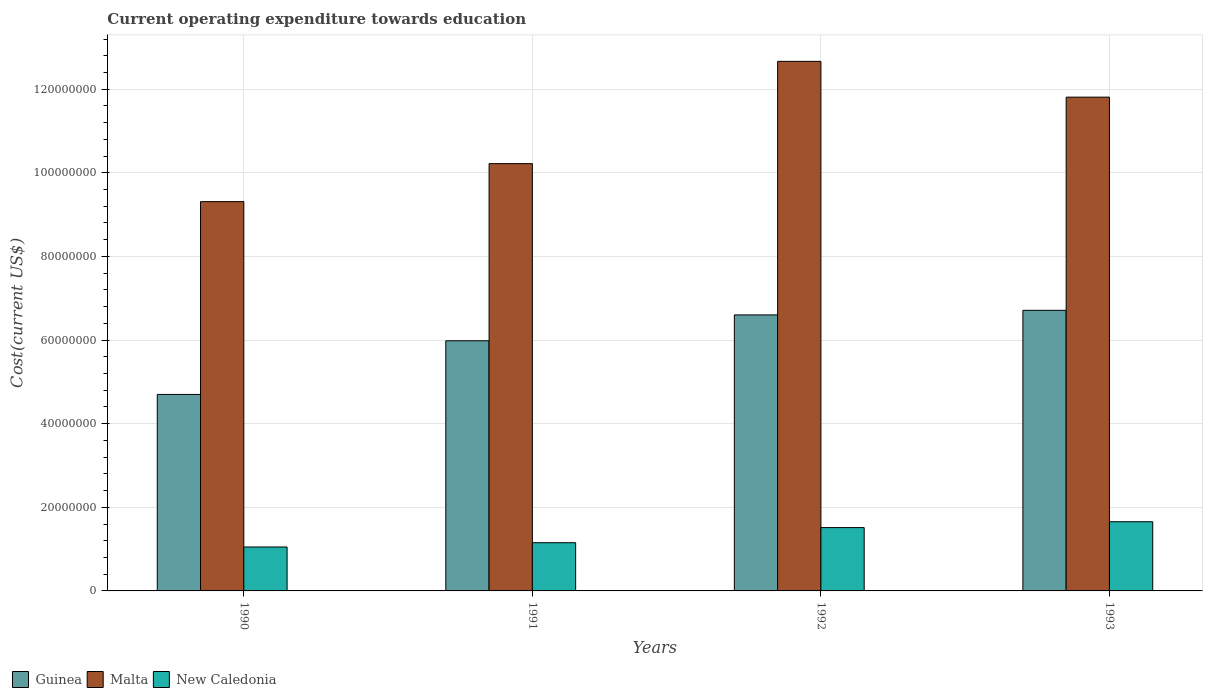How many different coloured bars are there?
Provide a succinct answer. 3. How many groups of bars are there?
Provide a succinct answer. 4. How many bars are there on the 2nd tick from the left?
Make the answer very short. 3. What is the label of the 2nd group of bars from the left?
Ensure brevity in your answer.  1991. In how many cases, is the number of bars for a given year not equal to the number of legend labels?
Your answer should be compact. 0. What is the expenditure towards education in New Caledonia in 1992?
Your answer should be very brief. 1.51e+07. Across all years, what is the maximum expenditure towards education in Guinea?
Your answer should be very brief. 6.71e+07. Across all years, what is the minimum expenditure towards education in Guinea?
Offer a terse response. 4.70e+07. In which year was the expenditure towards education in Malta minimum?
Offer a very short reply. 1990. What is the total expenditure towards education in New Caledonia in the graph?
Your response must be concise. 5.37e+07. What is the difference between the expenditure towards education in Malta in 1990 and that in 1993?
Offer a very short reply. -2.50e+07. What is the difference between the expenditure towards education in Malta in 1992 and the expenditure towards education in Guinea in 1990?
Your answer should be very brief. 7.97e+07. What is the average expenditure towards education in Guinea per year?
Offer a very short reply. 6.00e+07. In the year 1993, what is the difference between the expenditure towards education in Malta and expenditure towards education in New Caledonia?
Your answer should be very brief. 1.02e+08. In how many years, is the expenditure towards education in Malta greater than 100000000 US$?
Provide a succinct answer. 3. What is the ratio of the expenditure towards education in Malta in 1991 to that in 1992?
Make the answer very short. 0.81. Is the difference between the expenditure towards education in Malta in 1991 and 1992 greater than the difference between the expenditure towards education in New Caledonia in 1991 and 1992?
Give a very brief answer. No. What is the difference between the highest and the second highest expenditure towards education in New Caledonia?
Your answer should be compact. 1.40e+06. What is the difference between the highest and the lowest expenditure towards education in New Caledonia?
Offer a terse response. 6.04e+06. In how many years, is the expenditure towards education in Guinea greater than the average expenditure towards education in Guinea taken over all years?
Give a very brief answer. 2. What does the 3rd bar from the left in 1991 represents?
Offer a terse response. New Caledonia. What does the 2nd bar from the right in 1992 represents?
Your answer should be compact. Malta. Is it the case that in every year, the sum of the expenditure towards education in New Caledonia and expenditure towards education in Malta is greater than the expenditure towards education in Guinea?
Your response must be concise. Yes. Are all the bars in the graph horizontal?
Your response must be concise. No. What is the difference between two consecutive major ticks on the Y-axis?
Give a very brief answer. 2.00e+07. Are the values on the major ticks of Y-axis written in scientific E-notation?
Give a very brief answer. No. Does the graph contain any zero values?
Your answer should be very brief. No. Does the graph contain grids?
Your answer should be very brief. Yes. Where does the legend appear in the graph?
Offer a very short reply. Bottom left. How many legend labels are there?
Provide a short and direct response. 3. How are the legend labels stacked?
Your answer should be compact. Horizontal. What is the title of the graph?
Give a very brief answer. Current operating expenditure towards education. Does "Tunisia" appear as one of the legend labels in the graph?
Your answer should be very brief. No. What is the label or title of the Y-axis?
Keep it short and to the point. Cost(current US$). What is the Cost(current US$) of Guinea in 1990?
Provide a short and direct response. 4.70e+07. What is the Cost(current US$) in Malta in 1990?
Provide a succinct answer. 9.31e+07. What is the Cost(current US$) in New Caledonia in 1990?
Offer a very short reply. 1.05e+07. What is the Cost(current US$) of Guinea in 1991?
Provide a short and direct response. 5.98e+07. What is the Cost(current US$) in Malta in 1991?
Your response must be concise. 1.02e+08. What is the Cost(current US$) of New Caledonia in 1991?
Your answer should be very brief. 1.15e+07. What is the Cost(current US$) in Guinea in 1992?
Your answer should be compact. 6.60e+07. What is the Cost(current US$) of Malta in 1992?
Ensure brevity in your answer.  1.27e+08. What is the Cost(current US$) in New Caledonia in 1992?
Offer a terse response. 1.51e+07. What is the Cost(current US$) of Guinea in 1993?
Provide a succinct answer. 6.71e+07. What is the Cost(current US$) in Malta in 1993?
Your answer should be very brief. 1.18e+08. What is the Cost(current US$) of New Caledonia in 1993?
Keep it short and to the point. 1.65e+07. Across all years, what is the maximum Cost(current US$) of Guinea?
Your response must be concise. 6.71e+07. Across all years, what is the maximum Cost(current US$) in Malta?
Ensure brevity in your answer.  1.27e+08. Across all years, what is the maximum Cost(current US$) of New Caledonia?
Provide a short and direct response. 1.65e+07. Across all years, what is the minimum Cost(current US$) of Guinea?
Ensure brevity in your answer.  4.70e+07. Across all years, what is the minimum Cost(current US$) of Malta?
Keep it short and to the point. 9.31e+07. Across all years, what is the minimum Cost(current US$) in New Caledonia?
Make the answer very short. 1.05e+07. What is the total Cost(current US$) of Guinea in the graph?
Make the answer very short. 2.40e+08. What is the total Cost(current US$) of Malta in the graph?
Your answer should be compact. 4.40e+08. What is the total Cost(current US$) of New Caledonia in the graph?
Your response must be concise. 5.37e+07. What is the difference between the Cost(current US$) in Guinea in 1990 and that in 1991?
Make the answer very short. -1.28e+07. What is the difference between the Cost(current US$) in Malta in 1990 and that in 1991?
Make the answer very short. -9.09e+06. What is the difference between the Cost(current US$) of New Caledonia in 1990 and that in 1991?
Your response must be concise. -1.03e+06. What is the difference between the Cost(current US$) in Guinea in 1990 and that in 1992?
Keep it short and to the point. -1.90e+07. What is the difference between the Cost(current US$) in Malta in 1990 and that in 1992?
Offer a terse response. -3.36e+07. What is the difference between the Cost(current US$) of New Caledonia in 1990 and that in 1992?
Ensure brevity in your answer.  -4.64e+06. What is the difference between the Cost(current US$) of Guinea in 1990 and that in 1993?
Keep it short and to the point. -2.01e+07. What is the difference between the Cost(current US$) of Malta in 1990 and that in 1993?
Your answer should be very brief. -2.50e+07. What is the difference between the Cost(current US$) in New Caledonia in 1990 and that in 1993?
Keep it short and to the point. -6.04e+06. What is the difference between the Cost(current US$) of Guinea in 1991 and that in 1992?
Offer a terse response. -6.19e+06. What is the difference between the Cost(current US$) of Malta in 1991 and that in 1992?
Your answer should be very brief. -2.45e+07. What is the difference between the Cost(current US$) of New Caledonia in 1991 and that in 1992?
Provide a succinct answer. -3.62e+06. What is the difference between the Cost(current US$) in Guinea in 1991 and that in 1993?
Ensure brevity in your answer.  -7.28e+06. What is the difference between the Cost(current US$) of Malta in 1991 and that in 1993?
Offer a very short reply. -1.59e+07. What is the difference between the Cost(current US$) in New Caledonia in 1991 and that in 1993?
Offer a very short reply. -5.01e+06. What is the difference between the Cost(current US$) in Guinea in 1992 and that in 1993?
Your answer should be compact. -1.09e+06. What is the difference between the Cost(current US$) in Malta in 1992 and that in 1993?
Offer a terse response. 8.56e+06. What is the difference between the Cost(current US$) of New Caledonia in 1992 and that in 1993?
Your answer should be compact. -1.40e+06. What is the difference between the Cost(current US$) in Guinea in 1990 and the Cost(current US$) in Malta in 1991?
Ensure brevity in your answer.  -5.52e+07. What is the difference between the Cost(current US$) in Guinea in 1990 and the Cost(current US$) in New Caledonia in 1991?
Make the answer very short. 3.55e+07. What is the difference between the Cost(current US$) in Malta in 1990 and the Cost(current US$) in New Caledonia in 1991?
Provide a succinct answer. 8.16e+07. What is the difference between the Cost(current US$) in Guinea in 1990 and the Cost(current US$) in Malta in 1992?
Provide a short and direct response. -7.97e+07. What is the difference between the Cost(current US$) of Guinea in 1990 and the Cost(current US$) of New Caledonia in 1992?
Make the answer very short. 3.19e+07. What is the difference between the Cost(current US$) in Malta in 1990 and the Cost(current US$) in New Caledonia in 1992?
Your answer should be very brief. 7.80e+07. What is the difference between the Cost(current US$) of Guinea in 1990 and the Cost(current US$) of Malta in 1993?
Ensure brevity in your answer.  -7.11e+07. What is the difference between the Cost(current US$) of Guinea in 1990 and the Cost(current US$) of New Caledonia in 1993?
Offer a terse response. 3.05e+07. What is the difference between the Cost(current US$) in Malta in 1990 and the Cost(current US$) in New Caledonia in 1993?
Offer a terse response. 7.66e+07. What is the difference between the Cost(current US$) in Guinea in 1991 and the Cost(current US$) in Malta in 1992?
Give a very brief answer. -6.68e+07. What is the difference between the Cost(current US$) of Guinea in 1991 and the Cost(current US$) of New Caledonia in 1992?
Offer a terse response. 4.47e+07. What is the difference between the Cost(current US$) of Malta in 1991 and the Cost(current US$) of New Caledonia in 1992?
Your answer should be compact. 8.71e+07. What is the difference between the Cost(current US$) of Guinea in 1991 and the Cost(current US$) of Malta in 1993?
Your answer should be compact. -5.83e+07. What is the difference between the Cost(current US$) in Guinea in 1991 and the Cost(current US$) in New Caledonia in 1993?
Provide a short and direct response. 4.33e+07. What is the difference between the Cost(current US$) in Malta in 1991 and the Cost(current US$) in New Caledonia in 1993?
Offer a very short reply. 8.57e+07. What is the difference between the Cost(current US$) in Guinea in 1992 and the Cost(current US$) in Malta in 1993?
Offer a very short reply. -5.21e+07. What is the difference between the Cost(current US$) in Guinea in 1992 and the Cost(current US$) in New Caledonia in 1993?
Offer a terse response. 4.95e+07. What is the difference between the Cost(current US$) in Malta in 1992 and the Cost(current US$) in New Caledonia in 1993?
Provide a succinct answer. 1.10e+08. What is the average Cost(current US$) of Guinea per year?
Keep it short and to the point. 6.00e+07. What is the average Cost(current US$) in Malta per year?
Your response must be concise. 1.10e+08. What is the average Cost(current US$) in New Caledonia per year?
Make the answer very short. 1.34e+07. In the year 1990, what is the difference between the Cost(current US$) of Guinea and Cost(current US$) of Malta?
Ensure brevity in your answer.  -4.61e+07. In the year 1990, what is the difference between the Cost(current US$) of Guinea and Cost(current US$) of New Caledonia?
Ensure brevity in your answer.  3.65e+07. In the year 1990, what is the difference between the Cost(current US$) in Malta and Cost(current US$) in New Caledonia?
Your answer should be very brief. 8.26e+07. In the year 1991, what is the difference between the Cost(current US$) in Guinea and Cost(current US$) in Malta?
Provide a short and direct response. -4.24e+07. In the year 1991, what is the difference between the Cost(current US$) in Guinea and Cost(current US$) in New Caledonia?
Offer a very short reply. 4.83e+07. In the year 1991, what is the difference between the Cost(current US$) of Malta and Cost(current US$) of New Caledonia?
Offer a terse response. 9.07e+07. In the year 1992, what is the difference between the Cost(current US$) in Guinea and Cost(current US$) in Malta?
Keep it short and to the point. -6.06e+07. In the year 1992, what is the difference between the Cost(current US$) of Guinea and Cost(current US$) of New Caledonia?
Provide a succinct answer. 5.09e+07. In the year 1992, what is the difference between the Cost(current US$) of Malta and Cost(current US$) of New Caledonia?
Your answer should be very brief. 1.12e+08. In the year 1993, what is the difference between the Cost(current US$) in Guinea and Cost(current US$) in Malta?
Offer a very short reply. -5.10e+07. In the year 1993, what is the difference between the Cost(current US$) in Guinea and Cost(current US$) in New Caledonia?
Give a very brief answer. 5.06e+07. In the year 1993, what is the difference between the Cost(current US$) of Malta and Cost(current US$) of New Caledonia?
Provide a succinct answer. 1.02e+08. What is the ratio of the Cost(current US$) of Guinea in 1990 to that in 1991?
Ensure brevity in your answer.  0.79. What is the ratio of the Cost(current US$) in Malta in 1990 to that in 1991?
Make the answer very short. 0.91. What is the ratio of the Cost(current US$) of New Caledonia in 1990 to that in 1991?
Your answer should be very brief. 0.91. What is the ratio of the Cost(current US$) in Guinea in 1990 to that in 1992?
Your answer should be very brief. 0.71. What is the ratio of the Cost(current US$) of Malta in 1990 to that in 1992?
Give a very brief answer. 0.74. What is the ratio of the Cost(current US$) of New Caledonia in 1990 to that in 1992?
Offer a terse response. 0.69. What is the ratio of the Cost(current US$) in Guinea in 1990 to that in 1993?
Your response must be concise. 0.7. What is the ratio of the Cost(current US$) in Malta in 1990 to that in 1993?
Keep it short and to the point. 0.79. What is the ratio of the Cost(current US$) in New Caledonia in 1990 to that in 1993?
Your answer should be compact. 0.64. What is the ratio of the Cost(current US$) in Guinea in 1991 to that in 1992?
Make the answer very short. 0.91. What is the ratio of the Cost(current US$) in Malta in 1991 to that in 1992?
Ensure brevity in your answer.  0.81. What is the ratio of the Cost(current US$) in New Caledonia in 1991 to that in 1992?
Offer a terse response. 0.76. What is the ratio of the Cost(current US$) of Guinea in 1991 to that in 1993?
Provide a succinct answer. 0.89. What is the ratio of the Cost(current US$) of Malta in 1991 to that in 1993?
Make the answer very short. 0.87. What is the ratio of the Cost(current US$) in New Caledonia in 1991 to that in 1993?
Your answer should be very brief. 0.7. What is the ratio of the Cost(current US$) in Guinea in 1992 to that in 1993?
Make the answer very short. 0.98. What is the ratio of the Cost(current US$) in Malta in 1992 to that in 1993?
Give a very brief answer. 1.07. What is the ratio of the Cost(current US$) in New Caledonia in 1992 to that in 1993?
Offer a terse response. 0.92. What is the difference between the highest and the second highest Cost(current US$) of Guinea?
Provide a short and direct response. 1.09e+06. What is the difference between the highest and the second highest Cost(current US$) of Malta?
Provide a succinct answer. 8.56e+06. What is the difference between the highest and the second highest Cost(current US$) of New Caledonia?
Keep it short and to the point. 1.40e+06. What is the difference between the highest and the lowest Cost(current US$) of Guinea?
Give a very brief answer. 2.01e+07. What is the difference between the highest and the lowest Cost(current US$) in Malta?
Provide a succinct answer. 3.36e+07. What is the difference between the highest and the lowest Cost(current US$) of New Caledonia?
Ensure brevity in your answer.  6.04e+06. 